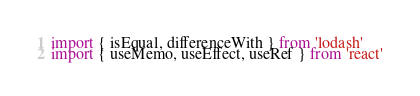Convert code to text. <code><loc_0><loc_0><loc_500><loc_500><_JavaScript_>import { isEqual, differenceWith } from 'lodash'
import { useMemo, useEffect, useRef } from 'react'</code> 